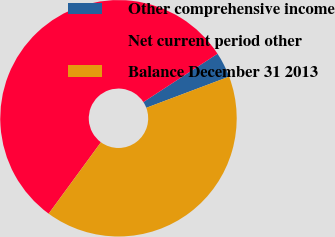Convert chart to OTSL. <chart><loc_0><loc_0><loc_500><loc_500><pie_chart><fcel>Other comprehensive income<fcel>Net current period other<fcel>Balance December 31 2013<nl><fcel>3.46%<fcel>55.75%<fcel>40.78%<nl></chart> 